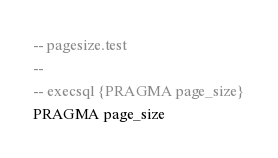<code> <loc_0><loc_0><loc_500><loc_500><_SQL_>-- pagesize.test
-- 
-- execsql {PRAGMA page_size}
PRAGMA page_size</code> 